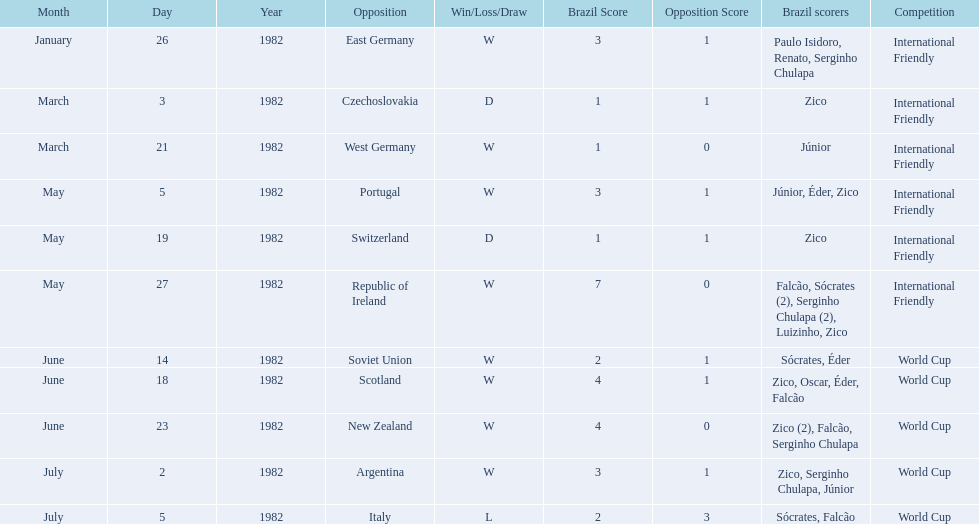Who won on january 26, 1982 and may 27, 1982? Brazil. 